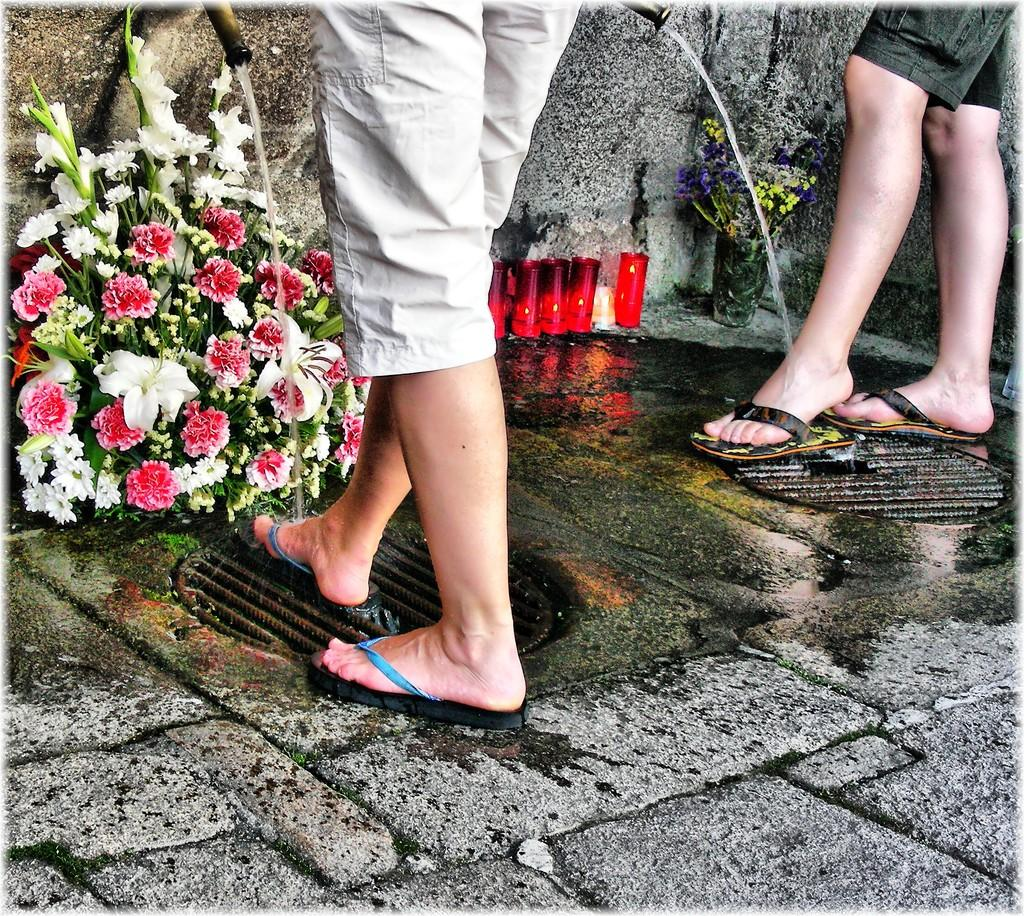What can be seen under the taps in the image? There are two persons' legs under the taps. What objects are present in the image besides the legs? There are two flower pots and a few candles in the image. How many clovers can be seen growing in the image? There are no clovers present in the image. What type of transport is being used by the persons in the image? The image does not show any type of transport; it only shows legs under the taps and other objects. 